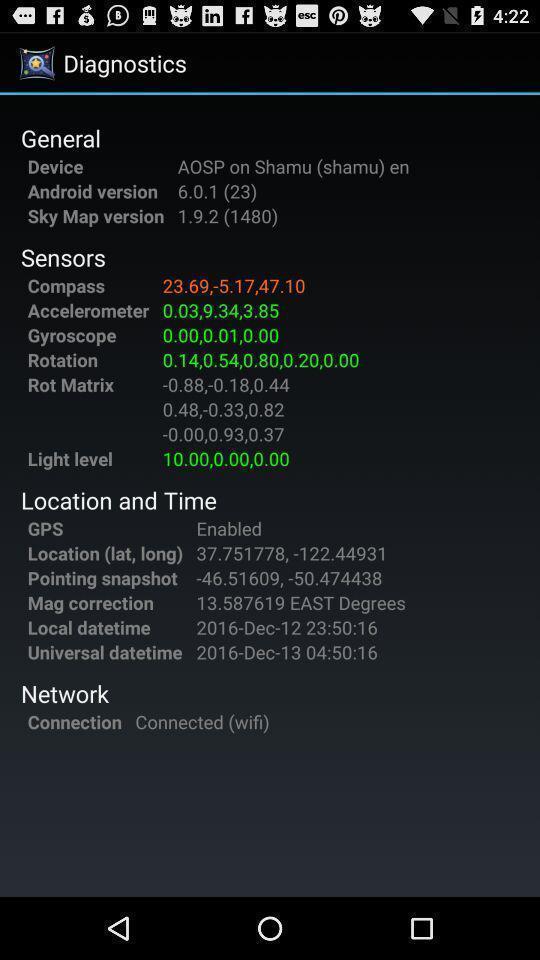Tell me what you see in this picture. Screen shows the diagnostics. 